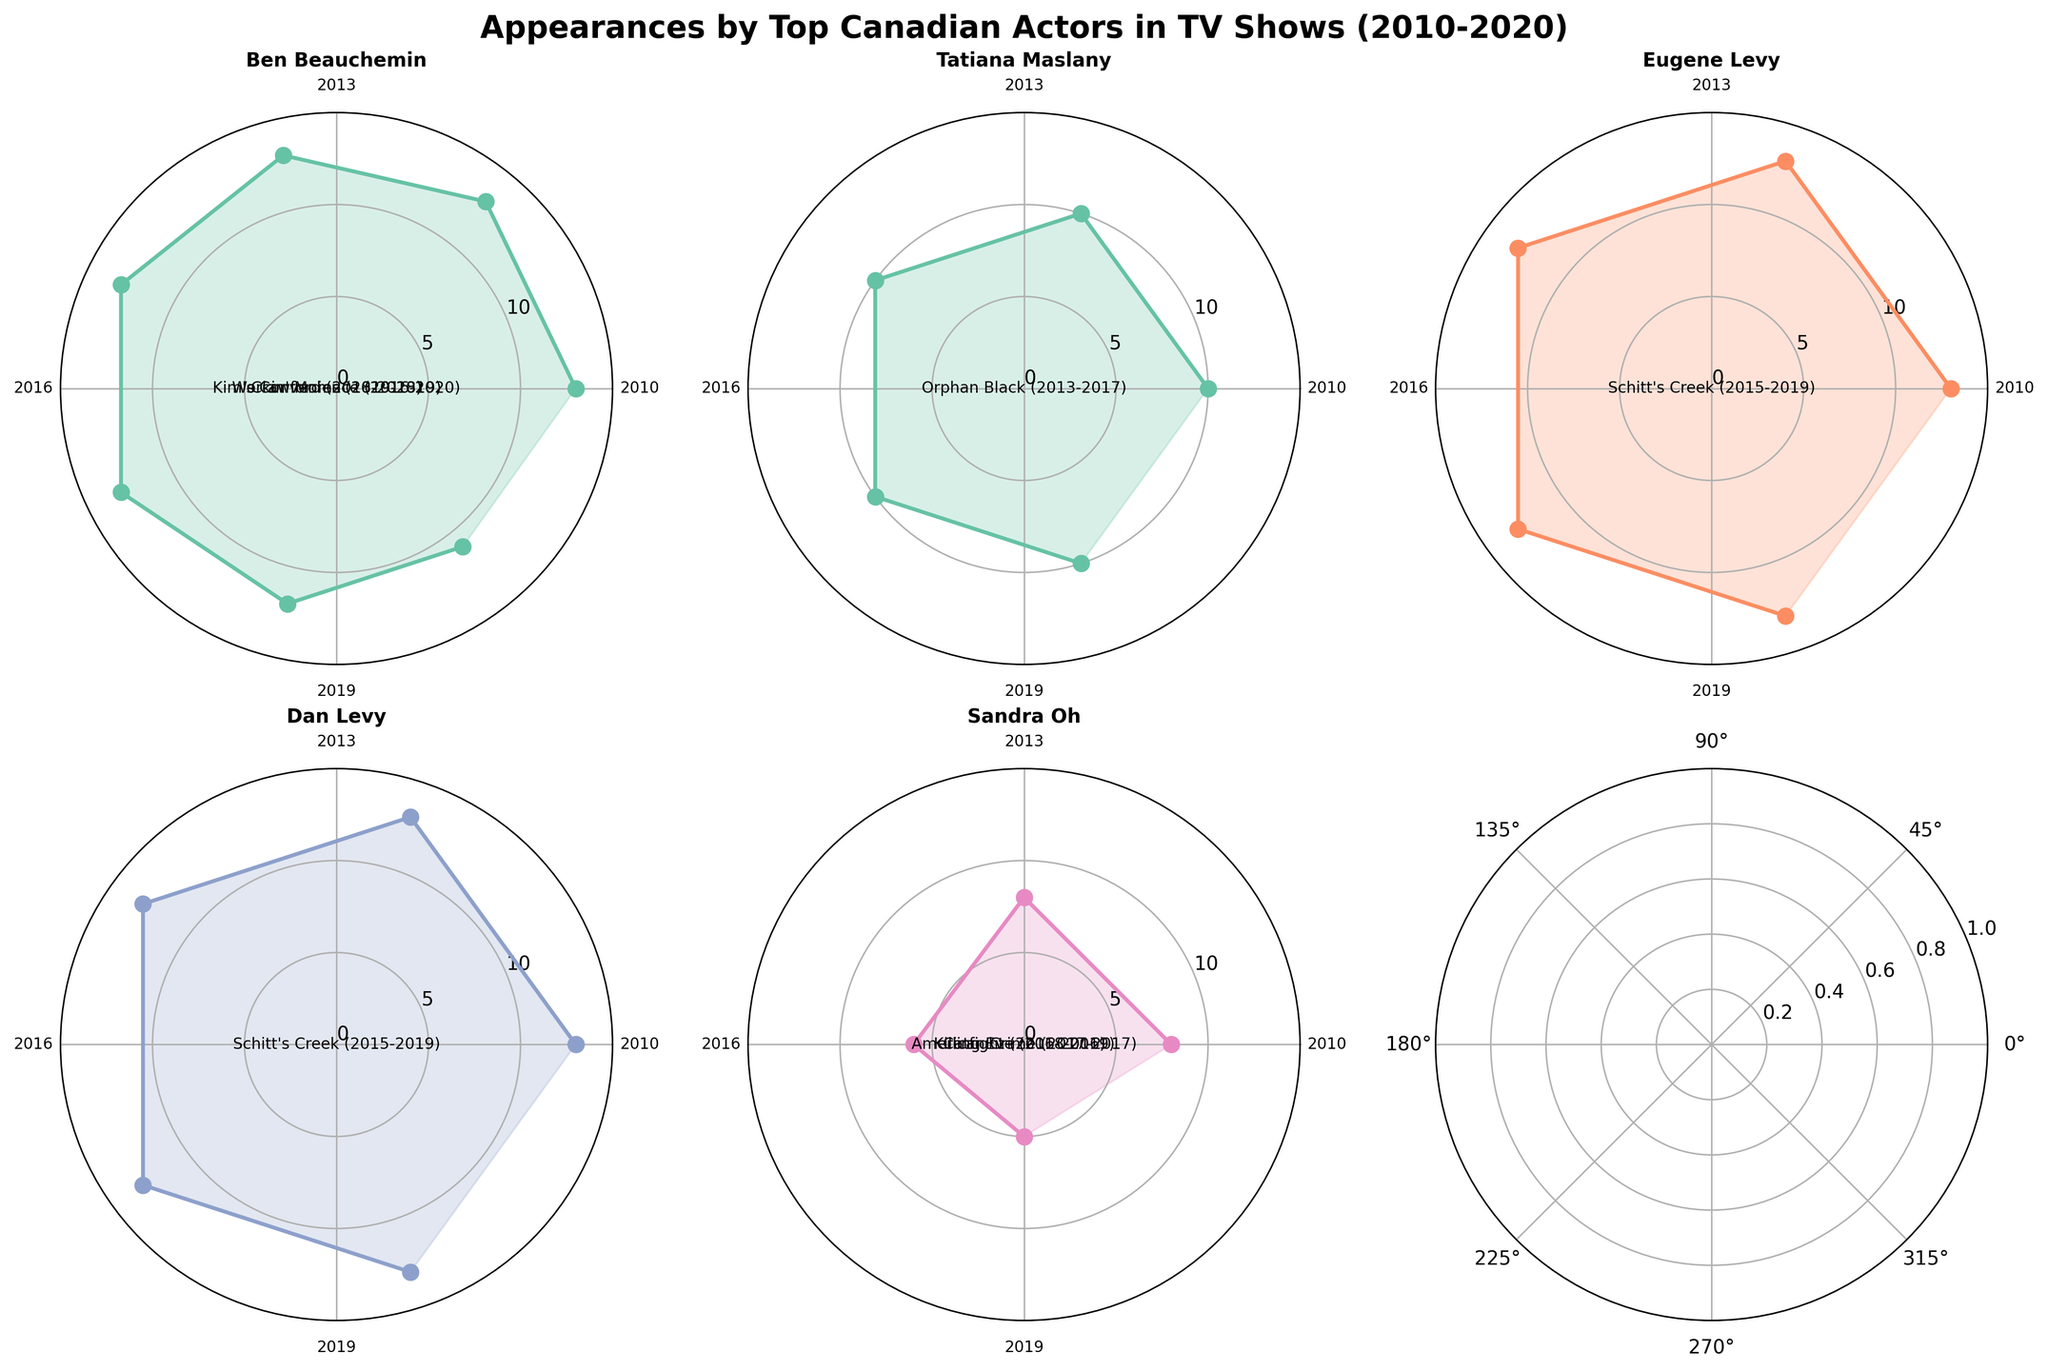What's the title of the figure? The title of a figure is usually located at the top and gives a brief description of what the figure represents. In this case, it is "Appearances by Top Canadian Actors in TV Shows (2010-2020)".
Answer: Appearances by Top Canadian Actors in TV Shows (2010-2020) Which actor has the most TV show appearances in a single year? Observing the maximum value of appearances for each actor, Ben Beauchemin and both Levy's show 13 appearances as the highest.
Answer: Ben Beauchemin, Eugene Levy, Dan Levy How many unique TV shows did Ben Beauchemin appear in over the past decade? By counting the number of unique TV shows listed for Ben Beauchemin, we see "Kim's Convenience", "Crawford", and "Workin' Moms", which totals to three.
Answer: 3 shows In which year did Tatiana Maslany have her first appearance in the dataset? By checking Tatiana Maslany's earliest year of appearance data, we find that she started appearing in 2013 in "Orphan Black".
Answer: 2013 Compare the number of appearances between Ben Beauchemin and Eugene Levy in 2018. Who appeared more? Identifying the 2018 appearances for both actors in the respective subplot polar charts, Ben starred in "Kim's Convenience" (13) and "Crawford" (12) totaling to 25. Eugene Levy appeared 13 times in "Schitt's Creek". Ben had more appearances.
Answer: Ben Beauchemin Which actress appeared in "Killing Eve" and when? Noticing the polar subplot for Sandra Oh, markers show she appeared in "Killing Eve" in 2018 and 2019, mentioned in annotations or labels within the subplot.
Answer: Sandra Oh, 2018 and 2019 How do the appearance trends of Dan Levy and Eugene Levy compare over the years? Both actors have a consistent 13 appearances per year for "Schitt's Creek" from 2015 to 2019, showing an equal and constant dataset in their subplot polar charts.
Answer: Equal and consistent Calculate the total TV show appearances for Sandra Oh across all years. Summing Sandra Oh's appearances, "Killing Eve" (8+8) and other appearances ("Catfight" 6, "American Crime" 5), a total is made. 8+8+6+5 = 27 appearances.
Answer: 27 appearances 